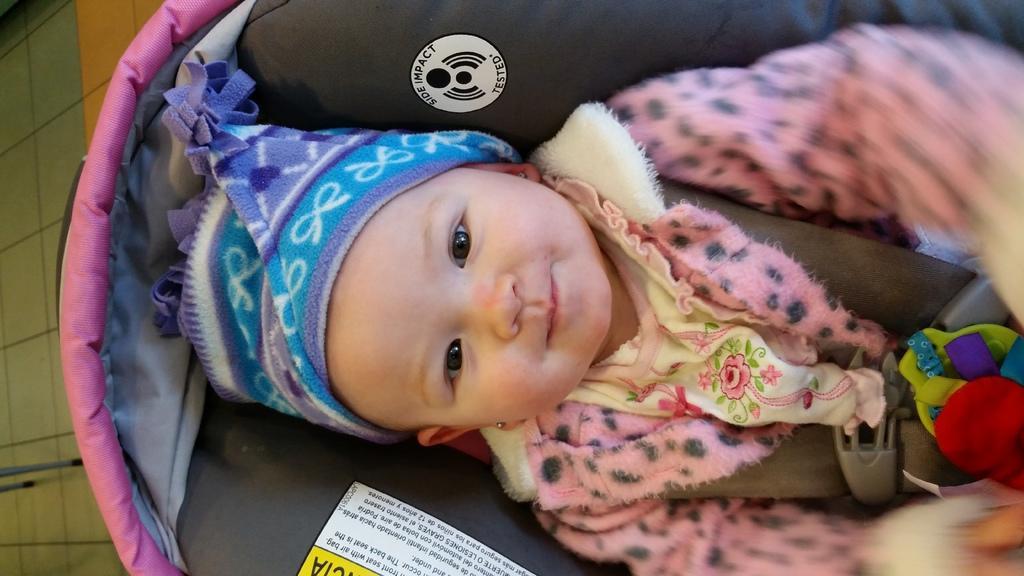Could you give a brief overview of what you see in this image? In this image we can see a baby lying in a baby carrier. On the left side we can see some poles on the floor. 